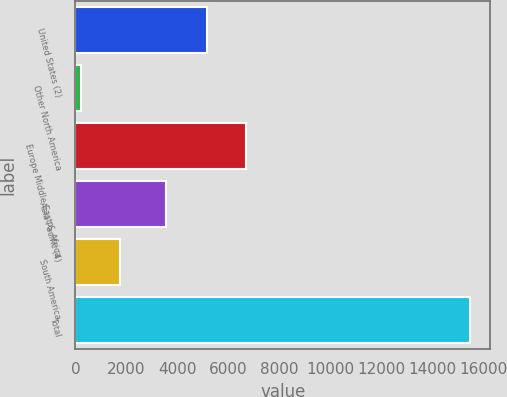Convert chart. <chart><loc_0><loc_0><loc_500><loc_500><bar_chart><fcel>United States (2)<fcel>Other North America<fcel>Europe Middle East & Africa<fcel>Asia Pacific (4)<fcel>South America<fcel>Total<nl><fcel>5160<fcel>208<fcel>6689.1<fcel>3552<fcel>1737.1<fcel>15499<nl></chart> 